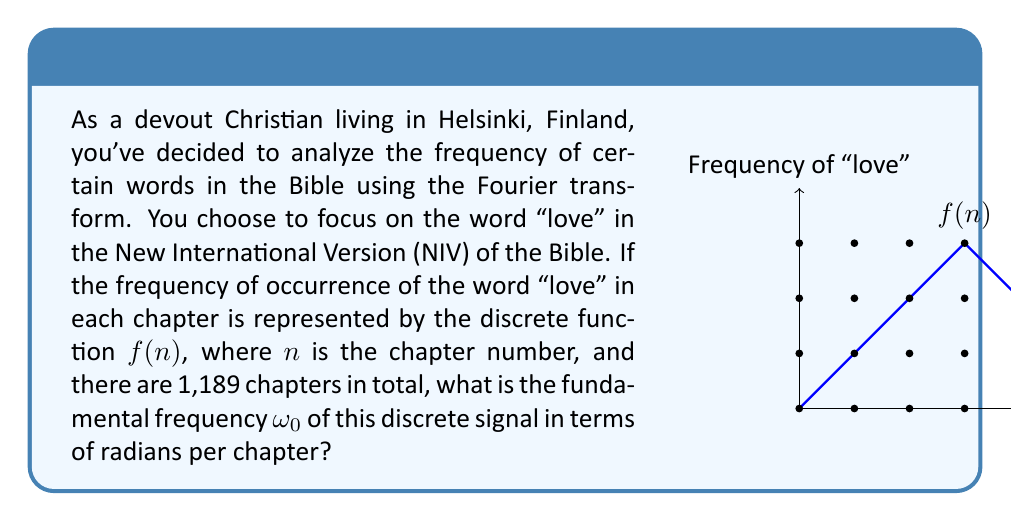What is the answer to this math problem? To solve this problem, let's follow these steps:

1) The Fourier transform is used to analyze periodic signals. In this case, we're treating the Bible as a periodic signal where the word "love" appears with varying frequency across chapters.

2) The fundamental frequency $\omega_0$ is the lowest frequency component of a periodic signal. It's related to the period of the signal.

3) For a discrete signal, the period is the total number of samples. In this case, it's the total number of chapters in the Bible, which is 1,189.

4) The fundamental frequency in radians per sample (or in our case, radians per chapter) is given by the formula:

   $$\omega_0 = \frac{2\pi}{N}$$

   Where $N$ is the total number of samples (chapters).

5) Substituting our value:

   $$\omega_0 = \frac{2\pi}{1189}$$

6) This fraction can't be simplified further, so this is our final answer.

Note: This fundamental frequency represents the lowest frequency component of the Fourier transform of our discrete signal $f(n)$. Higher frequency components would be integer multiples of this fundamental frequency.
Answer: $\frac{2\pi}{1189}$ radians/chapter 